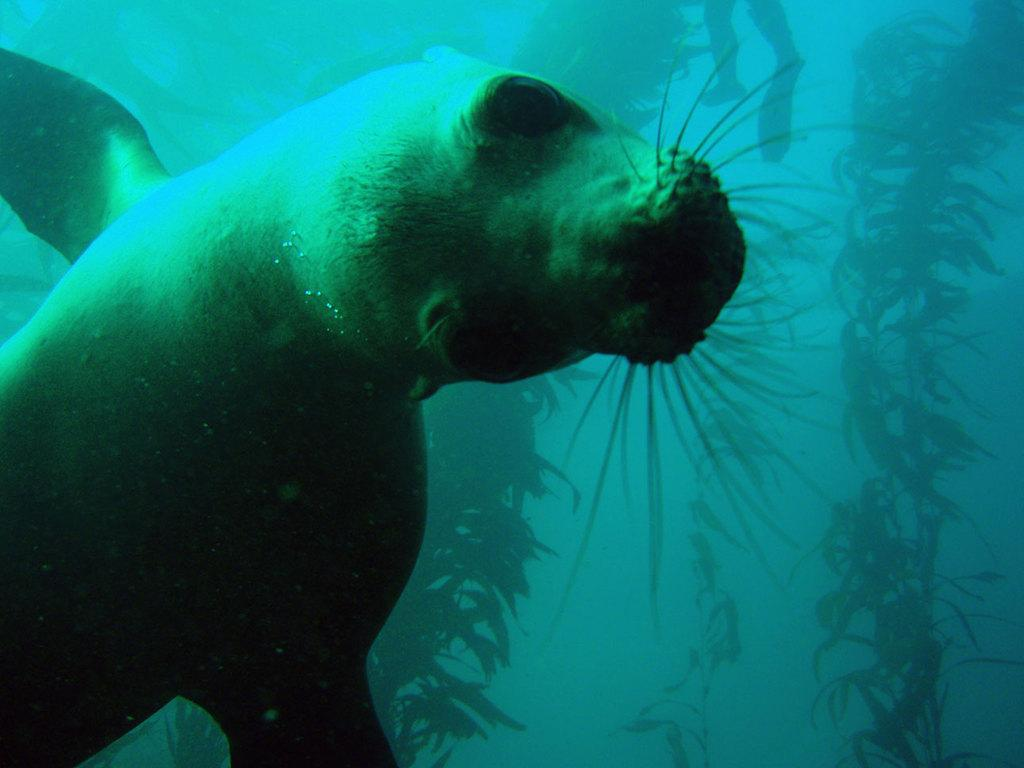What type of animal is in the image? There is a sea lion in the image. What is the environment like in the image? There are plants in the water in the image. Can you see any part of a person in the image? Yes, the legs of a person are visible at the top of the image. What type of letter is being written by the sea lion in the image? There is no letter being written by the sea lion in the image, as sea lions do not have the ability to write. 